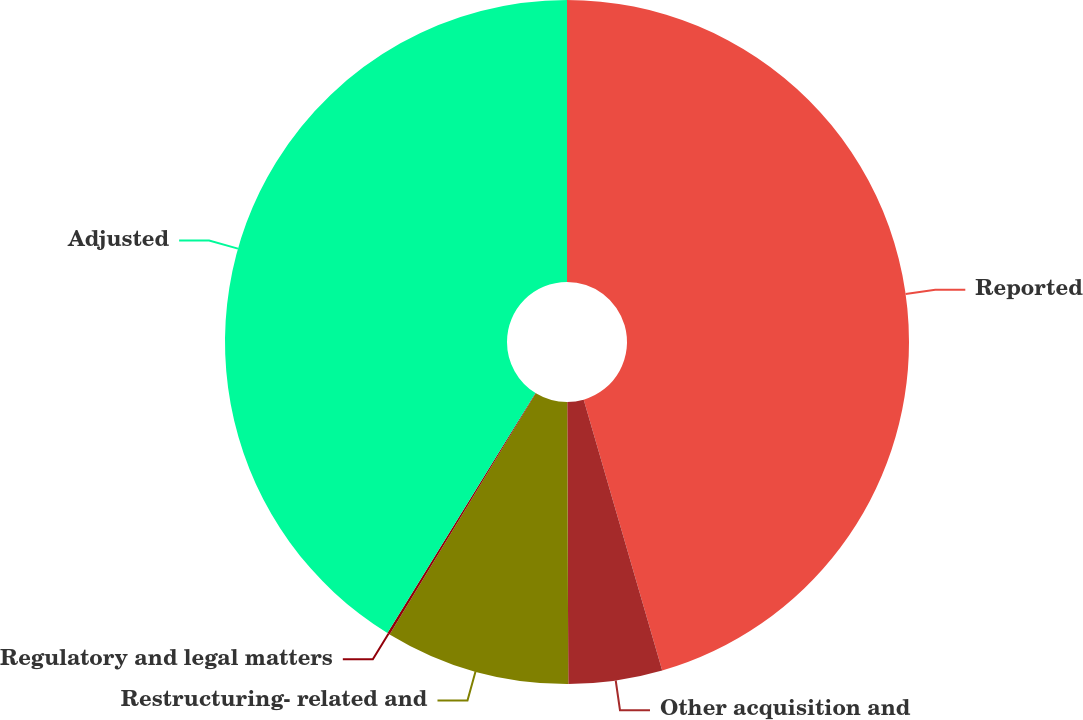<chart> <loc_0><loc_0><loc_500><loc_500><pie_chart><fcel>Reported<fcel>Other acquisition and<fcel>Restructuring- related and<fcel>Regulatory and legal matters<fcel>Adjusted<nl><fcel>45.51%<fcel>4.43%<fcel>8.74%<fcel>0.12%<fcel>41.2%<nl></chart> 